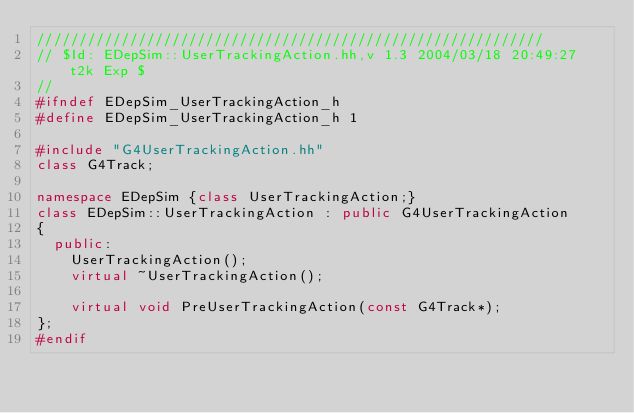<code> <loc_0><loc_0><loc_500><loc_500><_C++_>////////////////////////////////////////////////////////////
// $Id: EDepSim::UserTrackingAction.hh,v 1.3 2004/03/18 20:49:27 t2k Exp $
//
#ifndef EDepSim_UserTrackingAction_h
#define EDepSim_UserTrackingAction_h 1

#include "G4UserTrackingAction.hh"
class G4Track;

namespace EDepSim {class UserTrackingAction;}
class EDepSim::UserTrackingAction : public G4UserTrackingAction
{
  public:
    UserTrackingAction();
    virtual ~UserTrackingAction();

    virtual void PreUserTrackingAction(const G4Track*);
};
#endif
</code> 